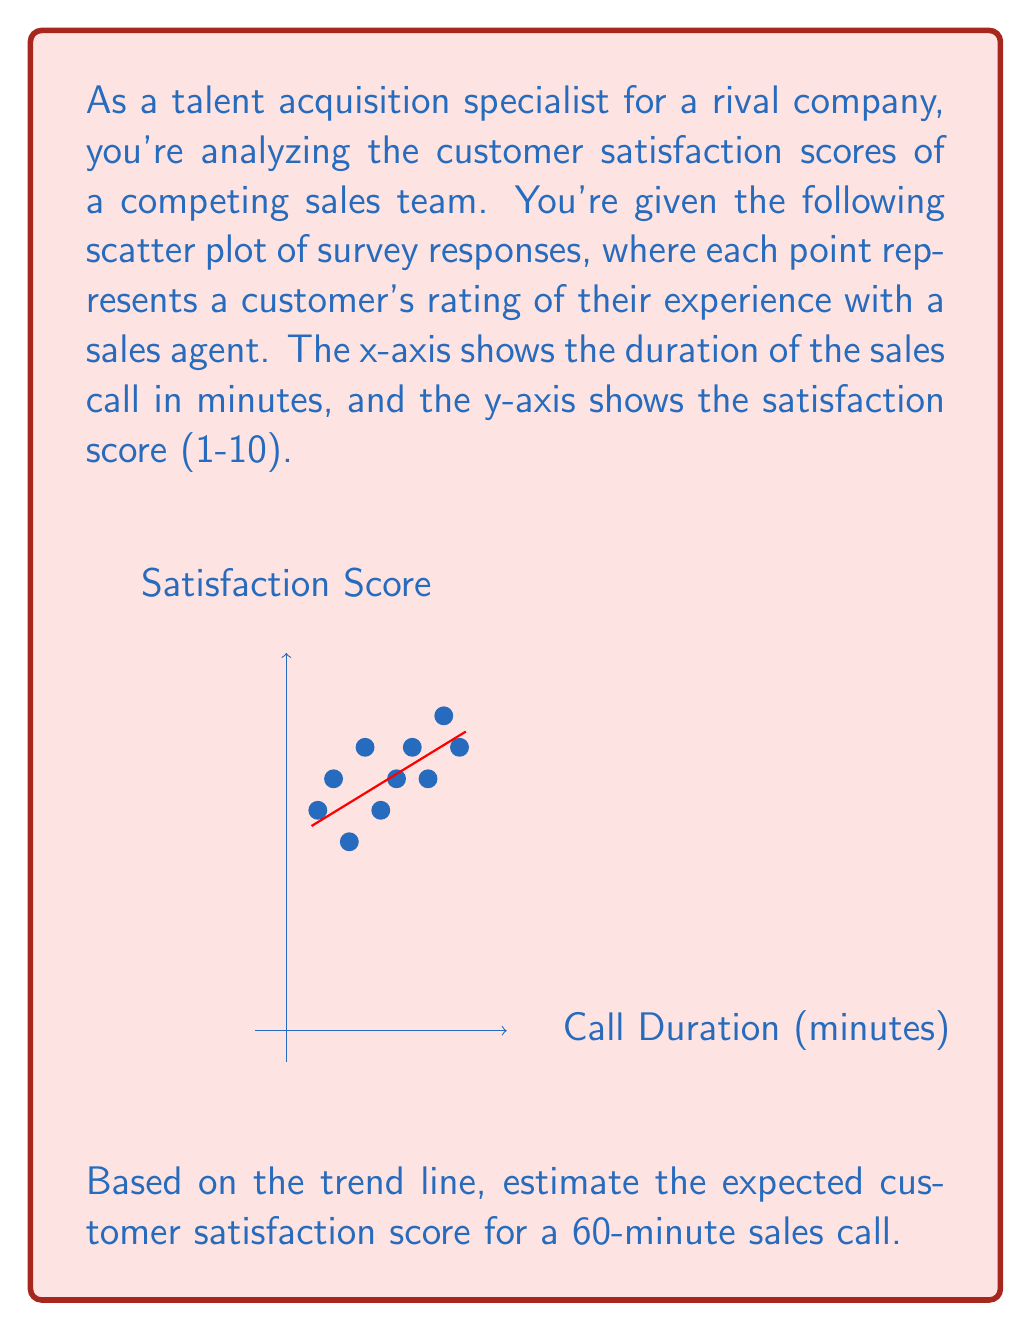Could you help me with this problem? To estimate the expected customer satisfaction score for a 60-minute sales call, we need to analyze the trend line in the scatter plot. Here's a step-by-step approach:

1) The trend line represents the general relationship between call duration and satisfaction score.

2) We need to find the slope and y-intercept of this line to create its equation.

3) Let's choose two points on the line to calculate the slope:
   Point 1: approximately (10, 6.75)
   Point 2: approximately (55, 9.25)

4) Calculate the slope:
   $$m = \frac{y_2 - y_1}{x_2 - x_1} = \frac{9.25 - 6.75}{55 - 10} = \frac{2.5}{45} \approx 0.0556$$

5) Now we can use the point-slope form of a line to find the y-intercept:
   $$y - y_1 = m(x - x_1)$$
   $$y - 6.75 = 0.0556(x - 10)$$
   $$y = 0.0556x + 6.194$$

6) We now have the equation of the trend line: $y = 0.0556x + 6.194$

7) To find the expected satisfaction score for a 60-minute call, we substitute x = 60:
   $$y = 0.0556(60) + 6.194 = 3.336 + 6.194 = 9.53$$

8) Rounding to the nearest tenth (as the satisfaction scores are given in whole numbers on the y-axis), we get 9.5.
Answer: 9.5 